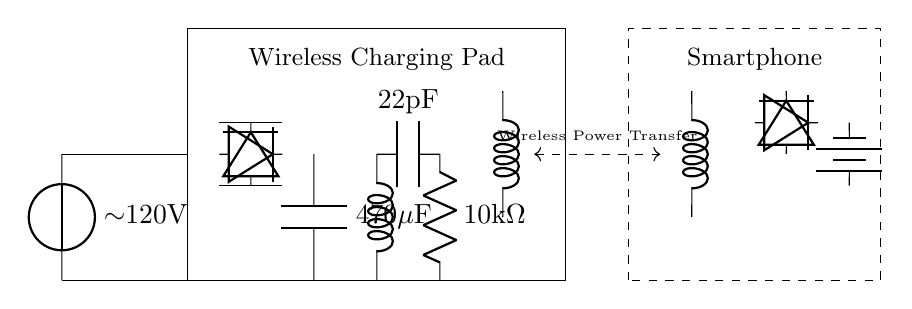What is the input voltage of the circuit? The input voltage is indicated as approximately 120 volts, coming from the AC power source shown on the left side of the diagram.
Answer: 120 volts What component smooths the rectified output? The smoothing capacitor, labeled as 470 microfarads, is the component that helps stabilize the output voltage after rectification.
Answer: 470 microfarads Name the type of circuit depicted. This circuit depicts a wireless charging circuit, which transfers power wirelessly to charge devices like smartphones.
Answer: Wireless charging How many diodes are used in the rectification process? There are a total of four diodes used in the rectification circuit, two at each of the given rectifier locations, which convert AC to DC.
Answer: Four What is the purpose of the transmitter coil? The transmitter coil is responsible for generating the magnetic field necessary for wireless power transfer to the receiver coil in the smartphone.
Answer: Generating magnetic field What is the purpose of the battery in the circuit? The battery stores the electrical energy received from the rectifier circuit and supplies power to the smartphone's internal circuits when needed.
Answer: Storing energy What component is used to regulate the frequency in this circuit? The oscillator portion of the circuit, which includes the cute inductor and the capacitor labeled 22 picofarads, works to regulate the frequency for efficient wireless charging.
Answer: Oscillator 